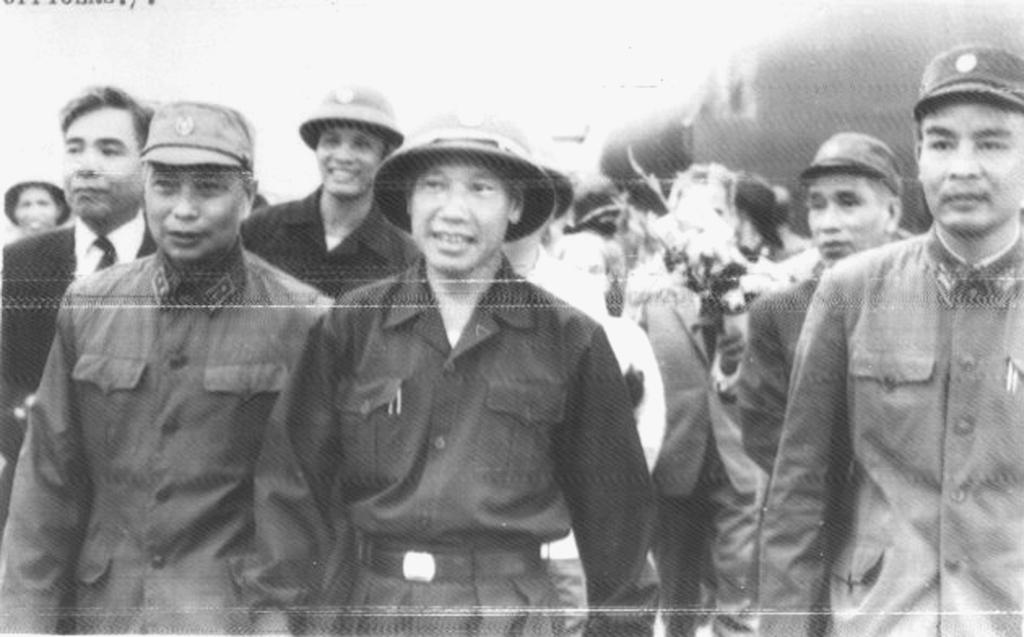Who or what is present in the image? There are people in the image. What are the people doing in the image? The people are walking. What type of clothing are the people wearing on their upper bodies? The people are wearing shirts and coats. What type of headwear are the people wearing in the image? The people are wearing hats. Are there any trees visible in the image? There is no mention of trees in the provided facts, so we cannot determine if they are present in the image. 